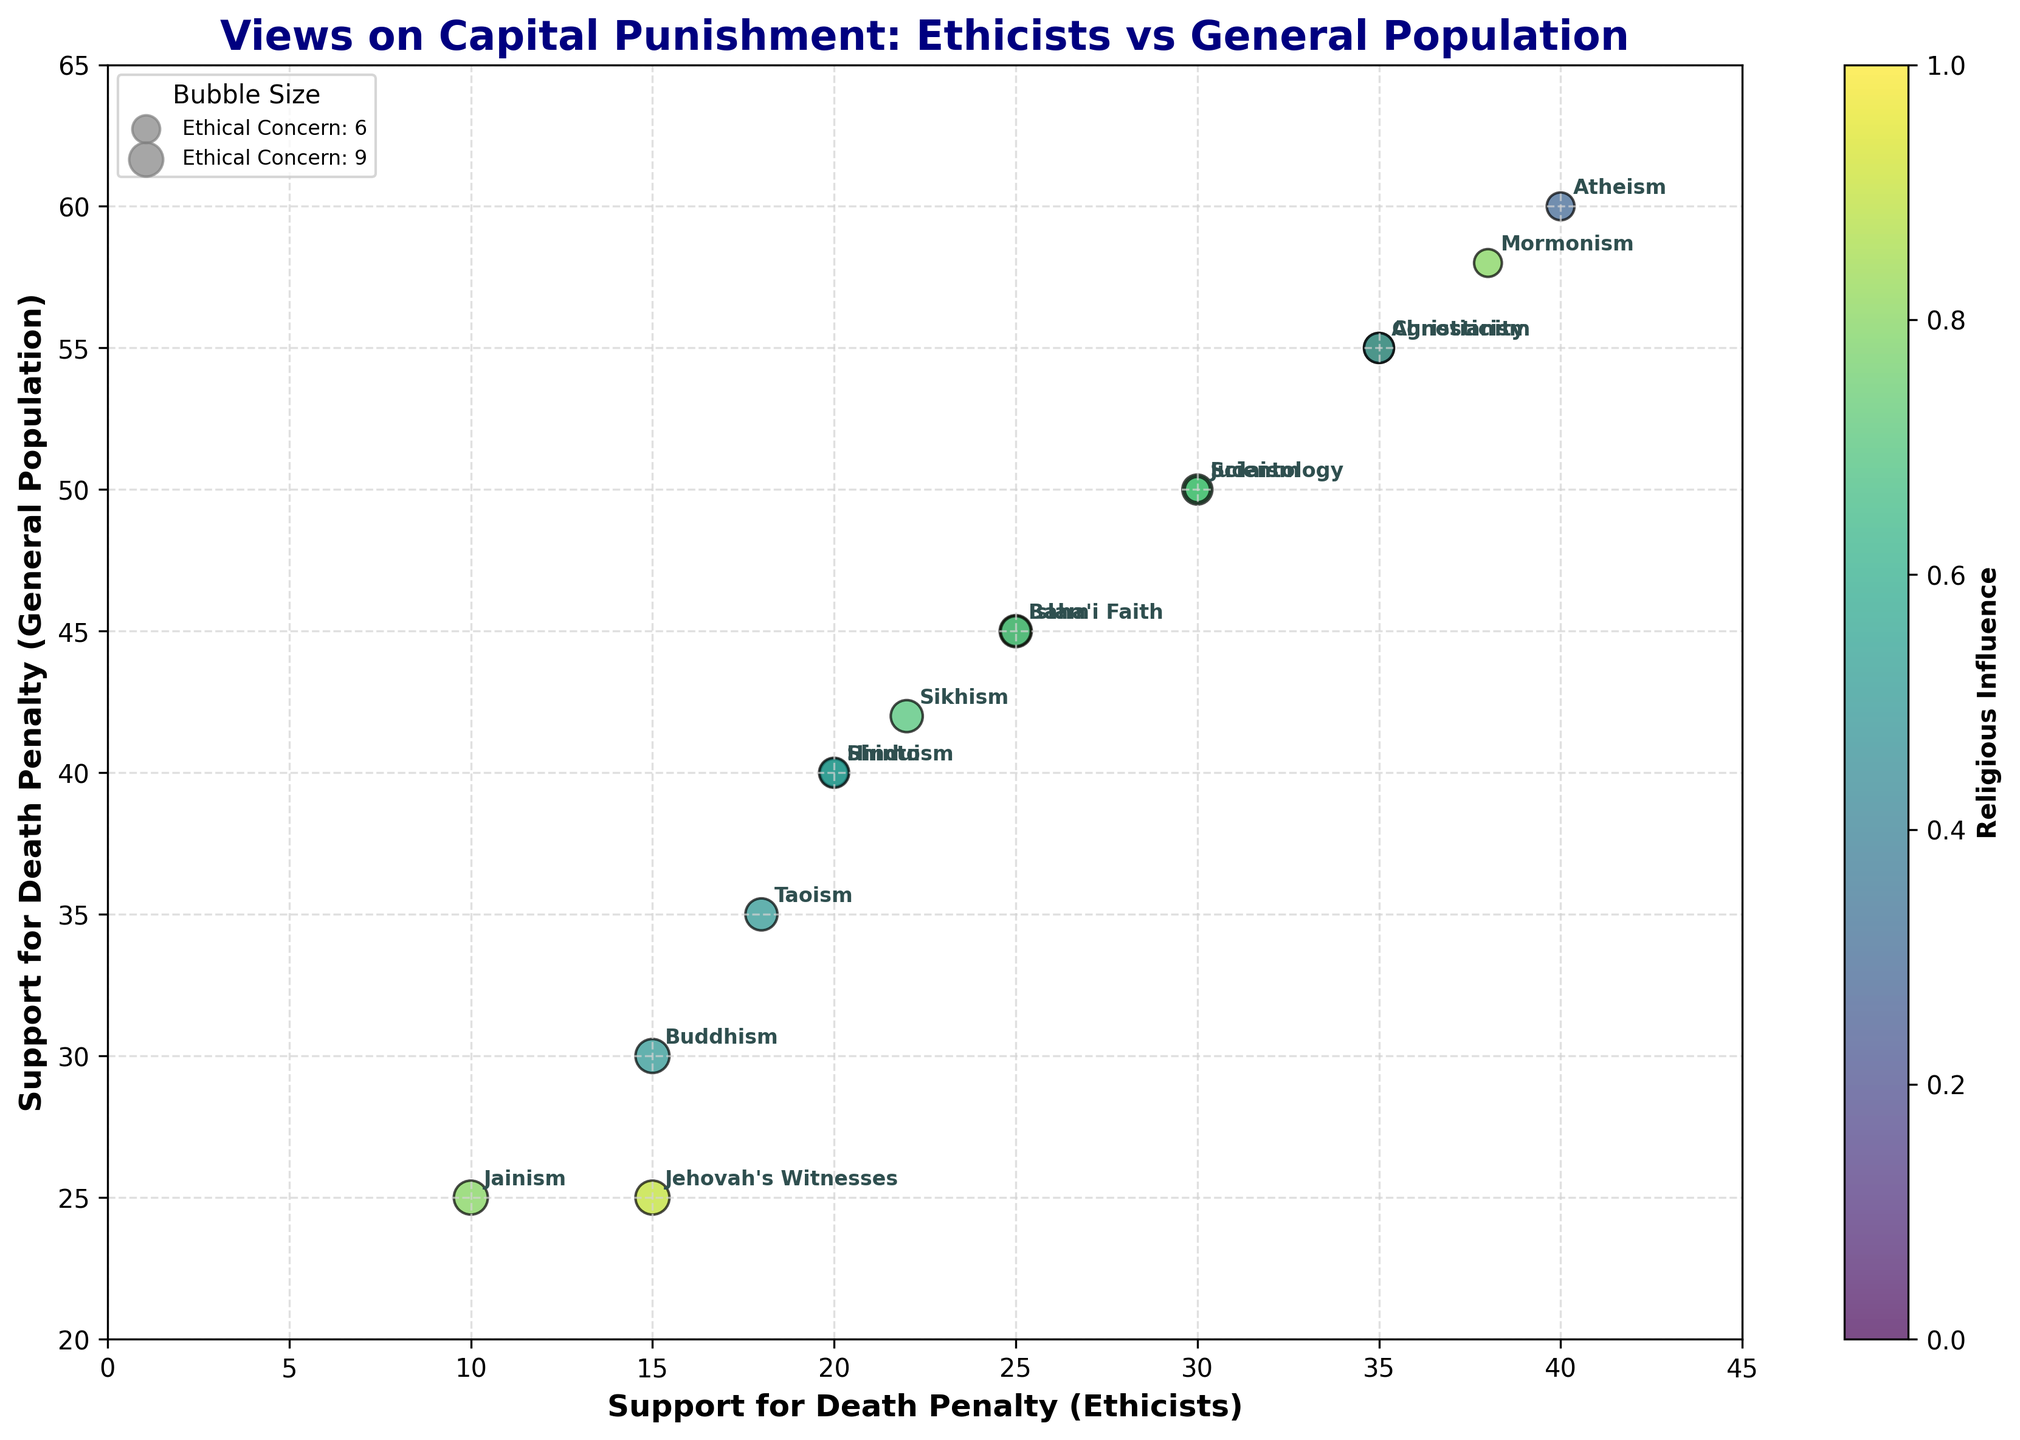How many religions are represented in the figure? By counting the number of unique labels in the plot, we can identify there are 15 different religions represented.
Answer: 15 Which religious affiliation shows the highest support for the death penalty among ethicists? From the figure, we see that Atheism has the highest support for the death penalty among ethicists with a value of 40.
Answer: Atheism What is the difference in death penalty support between ethicists and the general population for Scientology? For Scientology, the support among ethicists is 30 and among the general population is 50. The difference is calculated as 50 - 30 = 20.
Answer: 20 Which religion has the smallest bubble size on the plot and what is its ethical concern level? Jainism has the smallest bubble size, which corresponds to the highest ethical concern level of 9.
Answer: Jainism, 9 Which religion shows the least support for the death penalty among the general population? Jehovah's Witnesses show the least support for the death penalty among the general population with a value of 25.
Answer: Jehovah's Witnesses What is the range of religious influence scores shown in the color bar of the plot? From the color bar on the plot, the range of religious influence scores is from 3 to 9.
Answer: 3 to 9 Which religion has an ethical concern level of 6 and what is its support for the death penalty among ethicists? Hinduism, Atheism, and Mormonism all have an ethical concern level of 6. Specifically, for Hinduism, the support for the death penalty among ethicists is 20, for Atheism, it is 40, and for Mormonism, it is 38.
Answer: Hinduism: 20, Atheism: 40, Mormonism: 38 What is the bubble size for Christianity? The ethical concern level for Christianity is 7, so the bubble size is calculated as 7 * 20 = 140.
Answer: 140 How many religions have a religious influence score of 5? Buddhism, Taoism, and Shinto have a religious influence score of 5. This makes a total of 3 religions.
Answer: 3 Compare the support for the death penalty among the general population between Christianity and Islam. From the figure, support among the general population is 55 for Christianity and 45 for Islam. Christianity has 10 more support points than Islam.
Answer: Christianity, 10 